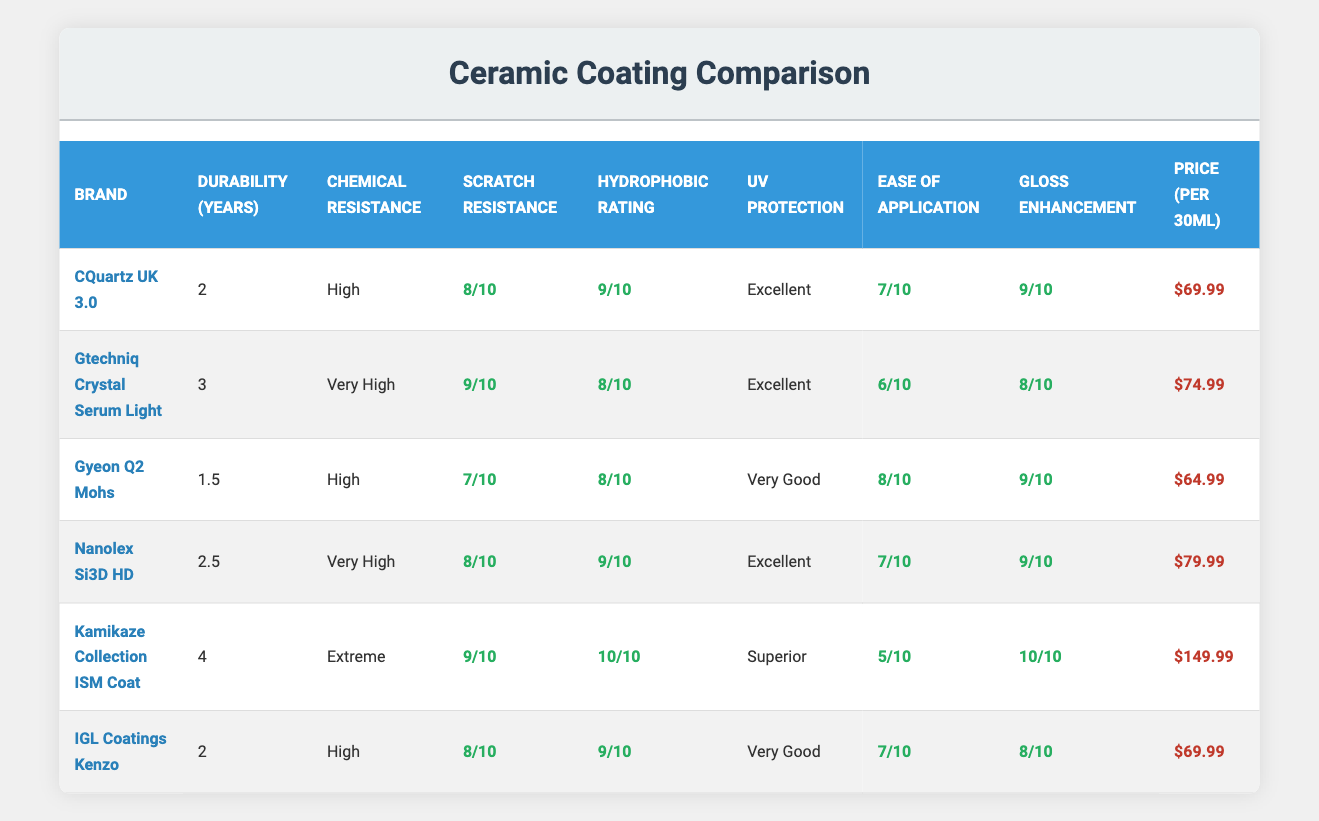What is the durability of Kamikaze Collection ISM Coat? The table indicates that the Kamikaze Collection ISM Coat has a durability of 4 years. This is directly found in the "Durability (Years)" column corresponding to that brand.
Answer: 4 years Which ceramic coating has the highest scratch resistance rating? Looking at the "Scratch Resistance" ratings in the table, both Gtechniq Crystal Serum Light and Kamikaze Collection ISM Coat have the highest rating of 9 out of 10.
Answer: Gtechniq Crystal Serum Light and Kamikaze Collection ISM Coat What is the average price per 30ml of the coatings in the table? To calculate the average price, add the prices of all coatings: 69.99 + 74.99 + 64.99 + 79.99 + 149.99 + 69.99 = 509.94. Then divide by the number of coatings (6): 509.94 / 6 = 84.99.
Answer: 84.99 Is the chemical resistance of Gyeon Q2 Mohs rated as "Very High"? The table shows that the chemical resistance of Gyeon Q2 Mohs is listed as "High," not "Very High." Therefore, this statement is false.
Answer: No Which coating offers the best UV protection? Kamikaze Collection ISM Coat is noted for its "Superior" UV protection, which is the highest rating given in the table. Therefore, it offers the best UV protection among the listed coatings.
Answer: Kamikaze Collection ISM Coat How many coatings have a hydrophobic rating of 9 or higher? Looking at the "Hydrophobic Rating" column, CQuartz UK 3.0, Nanolex Si3D HD, and Kamikaze Collection ISM Coat have ratings of 9 or 10. That makes a total of 3 coatings with a rating of 9 or higher.
Answer: 3 coatings If I want a coating that lasts at least 2 years, which options do I have? The table shows options such as CQuartz UK 3.0 (2 years), Gtechniq Crystal Serum Light (3 years), Nanolex Si3D HD (2.5 years), Kamikaze Collection ISM Coat (4 years), and IGL Coatings Kenzo (2 years). Therefore, there are 5 options available.
Answer: 5 options What is the difference in durability between Gtechniq Crystal Serum Light and Gyeon Q2 Mohs? Gtechniq Crystal Serum Light has a durability of 3 years, while Gyeon Q2 Mohs has 1.5 years. The difference is 3 - 1.5 = 1.5 years.
Answer: 1.5 years Does IGL Coatings Kenzo have a higher gloss enhancement rating than Gyeon Q2 Mohs? The table shows that IGL Coatings Kenzo has a gloss enhancement rating of 8, while Gyeon Q2 Mohs has a rating of 9. Therefore, IGL Coatings Kenzo does not have a higher rating.
Answer: No 